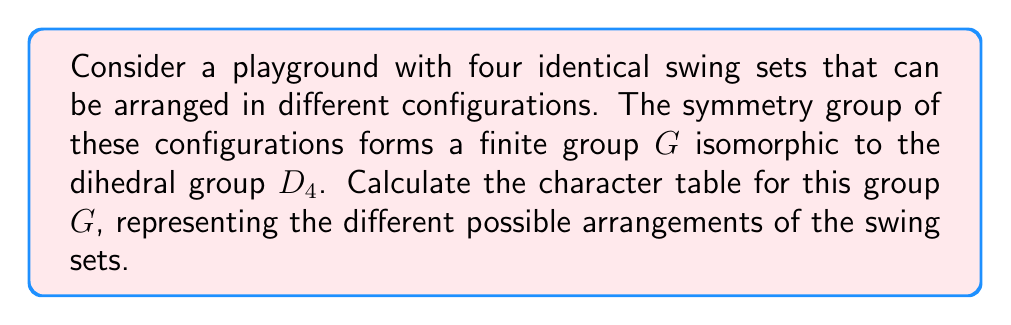Help me with this question. To calculate the character table for the group $G \cong D_4$, we'll follow these steps:

1. Identify the conjugacy classes of $G$:
   $G$ has 5 conjugacy classes: $\{e\}$, $\{r, r^3\}$, $\{r^2\}$, $\{s, sr^2\}$, $\{sr, sr^3\}$
   Where $e$ is the identity, $r$ is a 90-degree rotation, and $s$ is a reflection.

2. Determine the number of irreducible representations:
   The number of irreducible representations equals the number of conjugacy classes, which is 5.

3. Find the dimensions of the irreducible representations:
   We know that $\sum_{i=1}^{5} d_i^2 = |G| = 8$, where $d_i$ are the dimensions.
   The only solution is four 1-dimensional and one 2-dimensional representations.

4. Construct the character table:
   - The trivial representation $\chi_1$ has all characters 1.
   - For $\chi_2$, assign 1 to rotations and -1 to reflections.
   - For $\chi_3$, assign 1 to even rotations and -1 to odd rotations and reflections.
   - For $\chi_4$, assign 1 to rotations and horizontal/vertical reflections, -1 to diagonal reflections.
   - For $\chi_5$ (2-dimensional), use the formula $\chi_5(g) = 2\cos(\frac{2\pi k}{4})$ for rotations $r^k$, and 0 for reflections.

5. The resulting character table:

   $$\begin{array}{c|ccccc}
      G & \{e\} & \{r, r^3\} & \{r^2\} & \{s, sr^2\} & \{sr, sr^3\} \\
      \hline
      \chi_1 & 1 & 1 & 1 & 1 & 1 \\
      \chi_2 & 1 & 1 & 1 & -1 & -1 \\
      \chi_3 & 1 & -1 & 1 & 1 & -1 \\
      \chi_4 & 1 & -1 & 1 & -1 & 1 \\
      \chi_5 & 2 & 0 & -2 & 0 & 0
   \end{array}$$

This character table represents the different symmetries of the swing set configurations in the playground.
Answer: $$\begin{array}{c|ccccc}
   G & \{e\} & \{r, r^3\} & \{r^2\} & \{s, sr^2\} & \{sr, sr^3\} \\
   \hline
   \chi_1 & 1 & 1 & 1 & 1 & 1 \\
   \chi_2 & 1 & 1 & 1 & -1 & -1 \\
   \chi_3 & 1 & -1 & 1 & 1 & -1 \\
   \chi_4 & 1 & -1 & 1 & -1 & 1 \\
   \chi_5 & 2 & 0 & -2 & 0 & 0
\end{array}$$ 